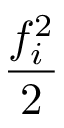<formula> <loc_0><loc_0><loc_500><loc_500>\frac { f _ { i } ^ { 2 } } { 2 }</formula> 